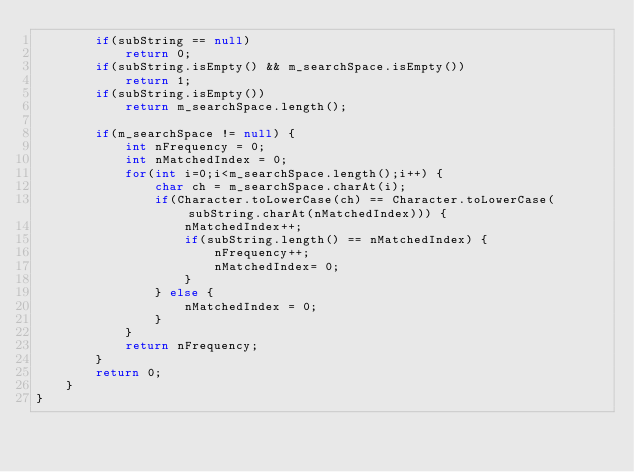<code> <loc_0><loc_0><loc_500><loc_500><_Java_>		if(subString == null)
			return 0;
		if(subString.isEmpty() && m_searchSpace.isEmpty())
			return 1;
		if(subString.isEmpty())
			return m_searchSpace.length();
		
		if(m_searchSpace != null) {
			int nFrequency = 0;
			int nMatchedIndex = 0;
			for(int i=0;i<m_searchSpace.length();i++) {
				char ch = m_searchSpace.charAt(i);
				if(Character.toLowerCase(ch) == Character.toLowerCase(subString.charAt(nMatchedIndex))) {
					nMatchedIndex++;
					if(subString.length() == nMatchedIndex) {
						nFrequency++;
						nMatchedIndex= 0;
					}
				} else {
					nMatchedIndex = 0;
				}
			}
			return nFrequency;
		}
		return 0;
	}
}
</code> 